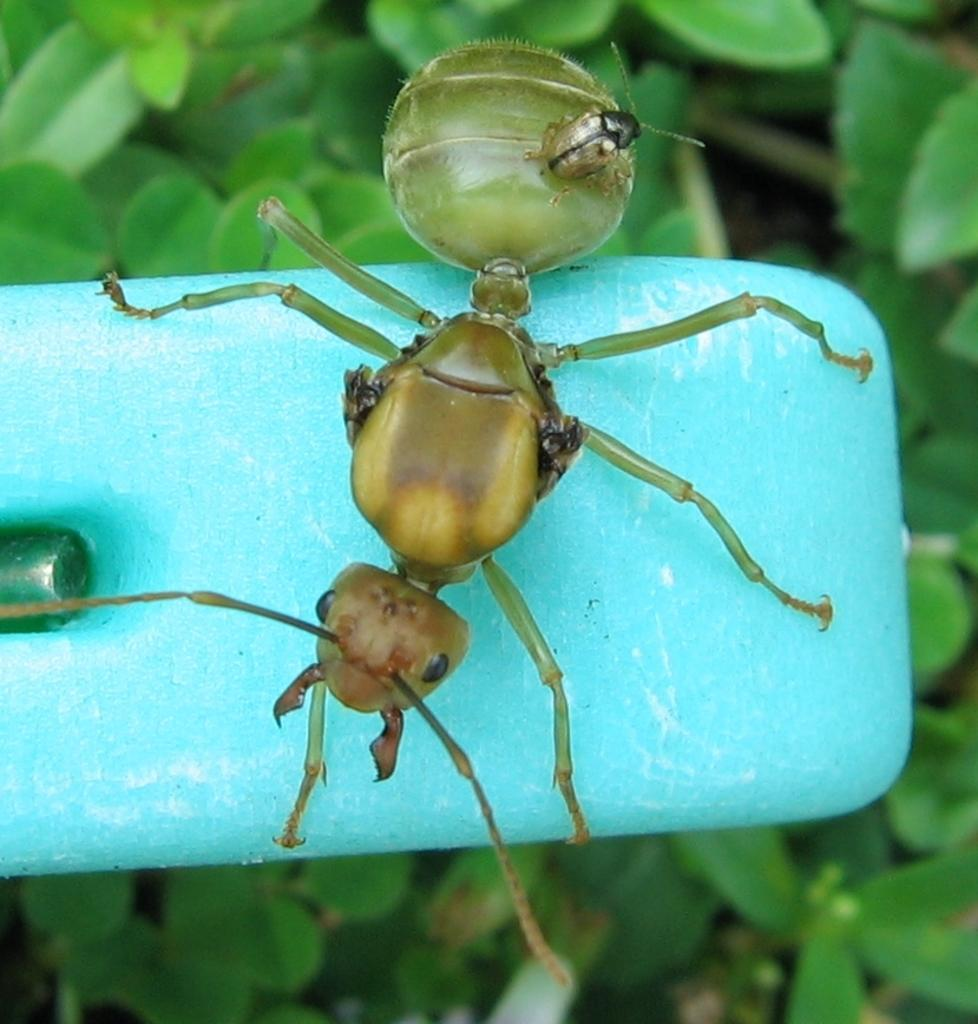What is the main subject of the image? There is an ant in the image. Where is the ant located? The ant is on a blue object. What can be seen in the background of the image? There are leaves in the background of the image. How many ants are involved in a fight in the image? There is only one ant present in the image, and no fighting is depicted. Can you describe the fly that is buzzing around the ant in the image? There is no fly present in the image; only the ant and the blue object are visible. 